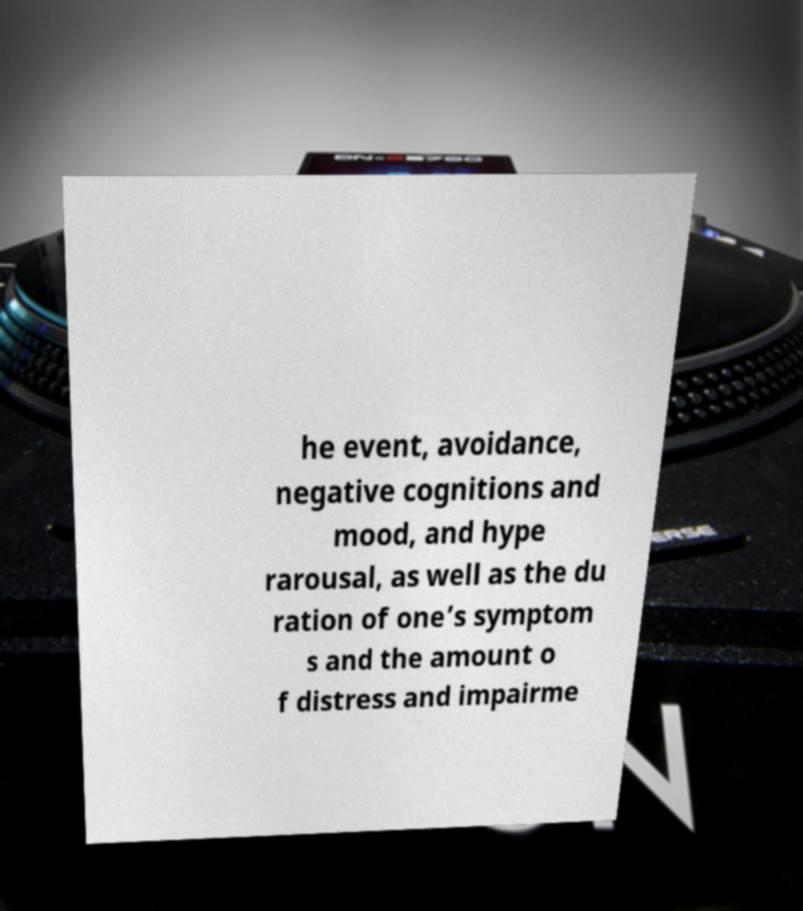Can you read and provide the text displayed in the image?This photo seems to have some interesting text. Can you extract and type it out for me? he event, avoidance, negative cognitions and mood, and hype rarousal, as well as the du ration of one’s symptom s and the amount o f distress and impairme 